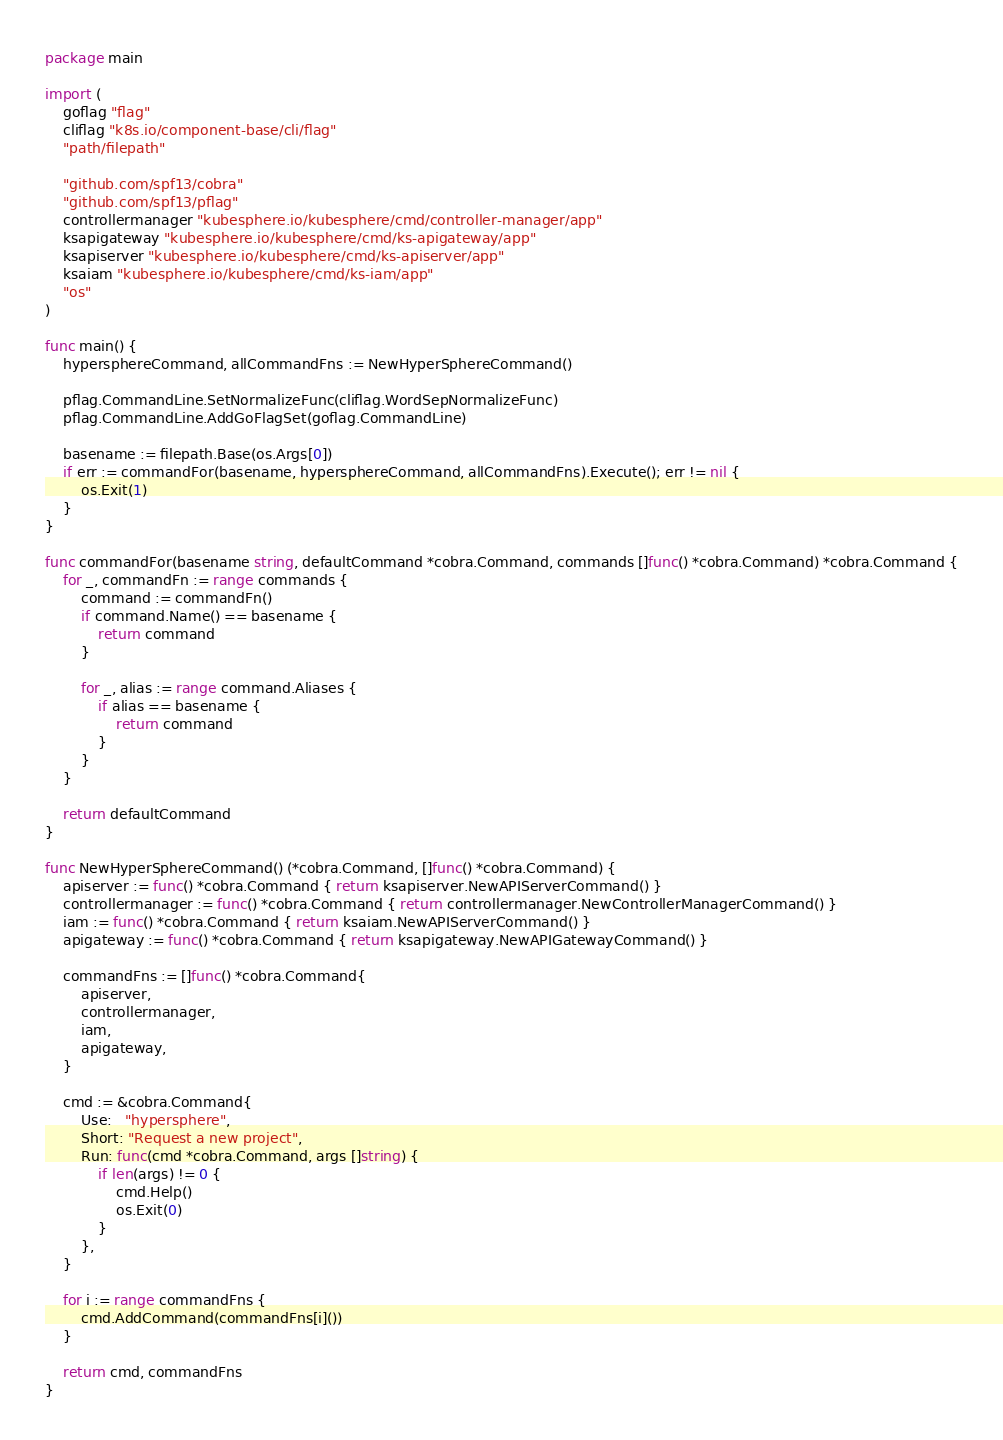<code> <loc_0><loc_0><loc_500><loc_500><_Go_>package main

import (
	goflag "flag"
	cliflag "k8s.io/component-base/cli/flag"
	"path/filepath"

	"github.com/spf13/cobra"
	"github.com/spf13/pflag"
	controllermanager "kubesphere.io/kubesphere/cmd/controller-manager/app"
	ksapigateway "kubesphere.io/kubesphere/cmd/ks-apigateway/app"
	ksapiserver "kubesphere.io/kubesphere/cmd/ks-apiserver/app"
	ksaiam "kubesphere.io/kubesphere/cmd/ks-iam/app"
	"os"
)

func main() {
	hypersphereCommand, allCommandFns := NewHyperSphereCommand()

	pflag.CommandLine.SetNormalizeFunc(cliflag.WordSepNormalizeFunc)
	pflag.CommandLine.AddGoFlagSet(goflag.CommandLine)

	basename := filepath.Base(os.Args[0])
	if err := commandFor(basename, hypersphereCommand, allCommandFns).Execute(); err != nil {
		os.Exit(1)
	}
}

func commandFor(basename string, defaultCommand *cobra.Command, commands []func() *cobra.Command) *cobra.Command {
	for _, commandFn := range commands {
		command := commandFn()
		if command.Name() == basename {
			return command
		}

		for _, alias := range command.Aliases {
			if alias == basename {
				return command
			}
		}
	}

	return defaultCommand
}

func NewHyperSphereCommand() (*cobra.Command, []func() *cobra.Command) {
	apiserver := func() *cobra.Command { return ksapiserver.NewAPIServerCommand() }
	controllermanager := func() *cobra.Command { return controllermanager.NewControllerManagerCommand() }
	iam := func() *cobra.Command { return ksaiam.NewAPIServerCommand() }
	apigateway := func() *cobra.Command { return ksapigateway.NewAPIGatewayCommand() }

	commandFns := []func() *cobra.Command{
		apiserver,
		controllermanager,
		iam,
		apigateway,
	}

	cmd := &cobra.Command{
		Use:   "hypersphere",
		Short: "Request a new project",
		Run: func(cmd *cobra.Command, args []string) {
			if len(args) != 0 {
				cmd.Help()
				os.Exit(0)
			}
		},
	}

	for i := range commandFns {
		cmd.AddCommand(commandFns[i]())
	}

	return cmd, commandFns
}
</code> 